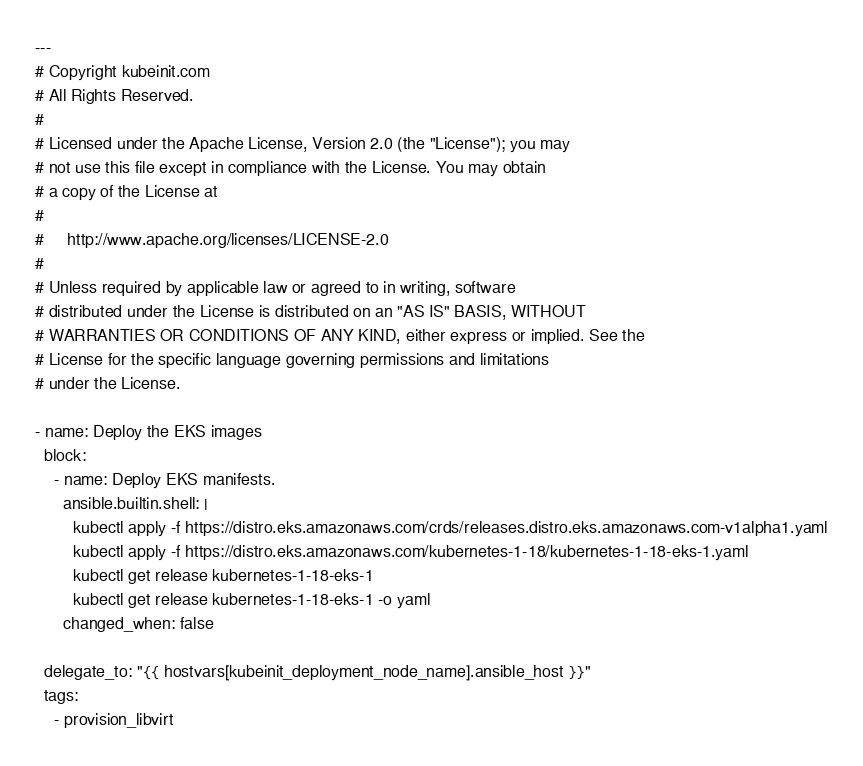Convert code to text. <code><loc_0><loc_0><loc_500><loc_500><_YAML_>---
# Copyright kubeinit.com
# All Rights Reserved.
#
# Licensed under the Apache License, Version 2.0 (the "License"); you may
# not use this file except in compliance with the License. You may obtain
# a copy of the License at
#
#     http://www.apache.org/licenses/LICENSE-2.0
#
# Unless required by applicable law or agreed to in writing, software
# distributed under the License is distributed on an "AS IS" BASIS, WITHOUT
# WARRANTIES OR CONDITIONS OF ANY KIND, either express or implied. See the
# License for the specific language governing permissions and limitations
# under the License.

- name: Deploy the EKS images
  block:
    - name: Deploy EKS manifests.
      ansible.builtin.shell: |
        kubectl apply -f https://distro.eks.amazonaws.com/crds/releases.distro.eks.amazonaws.com-v1alpha1.yaml
        kubectl apply -f https://distro.eks.amazonaws.com/kubernetes-1-18/kubernetes-1-18-eks-1.yaml
        kubectl get release kubernetes-1-18-eks-1
        kubectl get release kubernetes-1-18-eks-1 -o yaml
      changed_when: false

  delegate_to: "{{ hostvars[kubeinit_deployment_node_name].ansible_host }}"
  tags:
    - provision_libvirt
</code> 